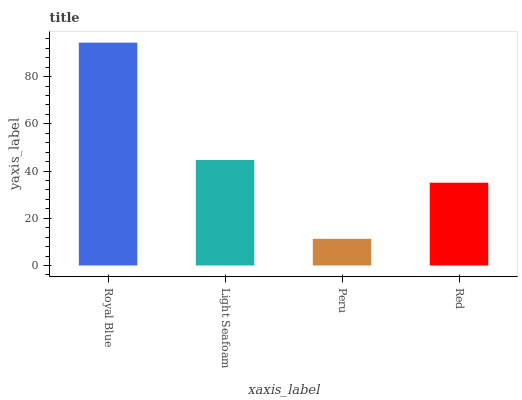Is Light Seafoam the minimum?
Answer yes or no. No. Is Light Seafoam the maximum?
Answer yes or no. No. Is Royal Blue greater than Light Seafoam?
Answer yes or no. Yes. Is Light Seafoam less than Royal Blue?
Answer yes or no. Yes. Is Light Seafoam greater than Royal Blue?
Answer yes or no. No. Is Royal Blue less than Light Seafoam?
Answer yes or no. No. Is Light Seafoam the high median?
Answer yes or no. Yes. Is Red the low median?
Answer yes or no. Yes. Is Royal Blue the high median?
Answer yes or no. No. Is Light Seafoam the low median?
Answer yes or no. No. 